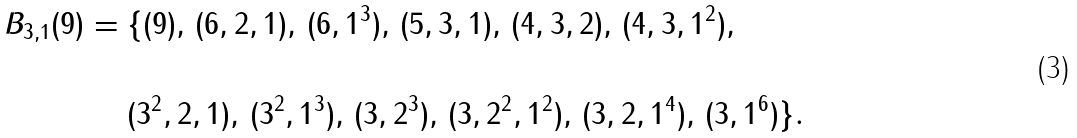<formula> <loc_0><loc_0><loc_500><loc_500>B _ { 3 , 1 } ( 9 ) & = \{ ( 9 ) , \, ( 6 , 2 , 1 ) , \, ( 6 , 1 ^ { 3 } ) , \, ( 5 , 3 , 1 ) , \, ( 4 , 3 , 2 ) , \, ( 4 , 3 , 1 ^ { 2 } ) , \, \\ & \\ & \quad \ ( 3 ^ { 2 } , 2 , 1 ) , \, ( 3 ^ { 2 } , 1 ^ { 3 } ) , \, ( 3 , 2 ^ { 3 } ) , \, ( 3 , 2 ^ { 2 } , 1 ^ { 2 } ) , \, ( 3 , 2 , 1 ^ { 4 } ) , \, ( 3 , 1 ^ { 6 } ) \} .</formula> 